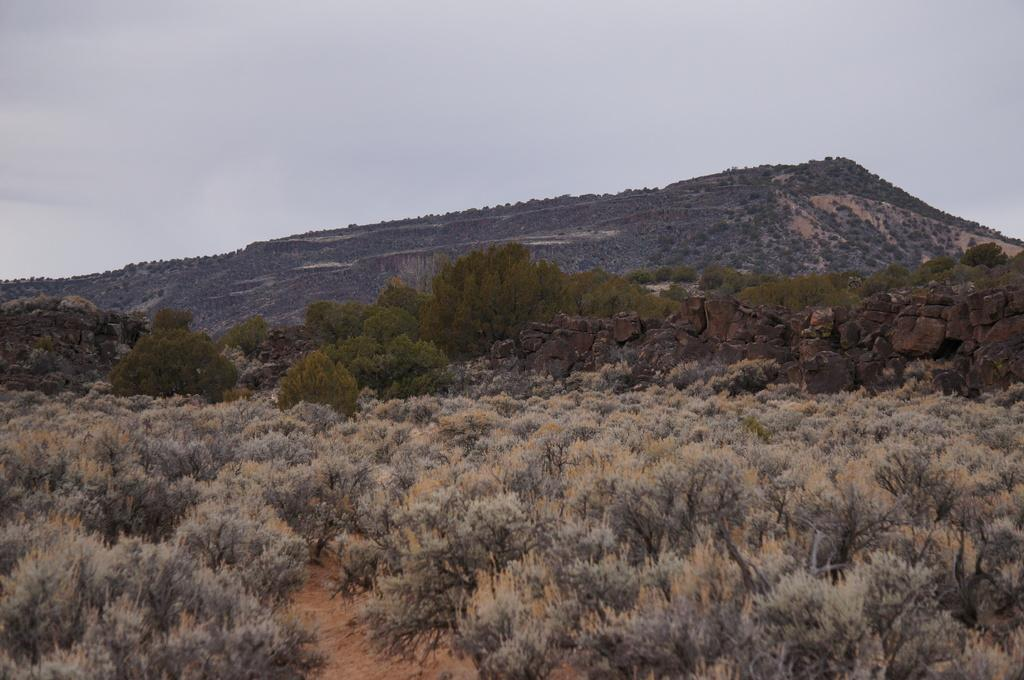What type of natural elements can be seen in the image? There are plants, trees, and rocks visible in the image. What is visible in the background of the image? The sky and a hill are visible in the background of the image. What type of worm can be seen crawling on the plants in the image? There are no worms present in the image; it only features plants, trees, rocks, the sky, and a hill. 